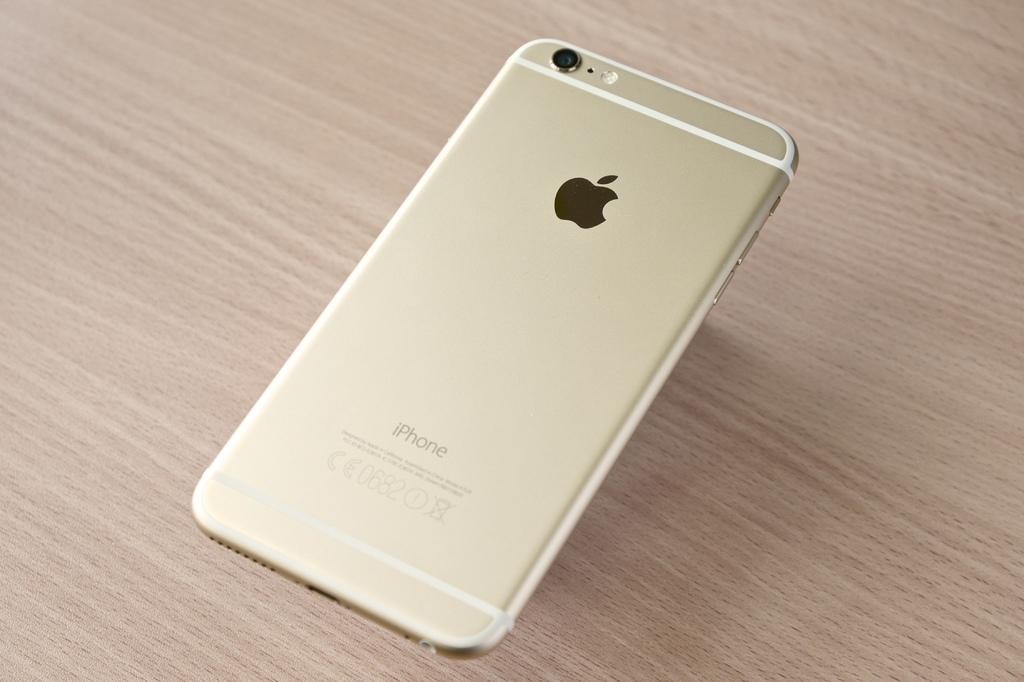What brand of phone is this?
Offer a terse response. Iphone. Who makes this phone?
Provide a short and direct response. Answering does not require reading text in the image. 